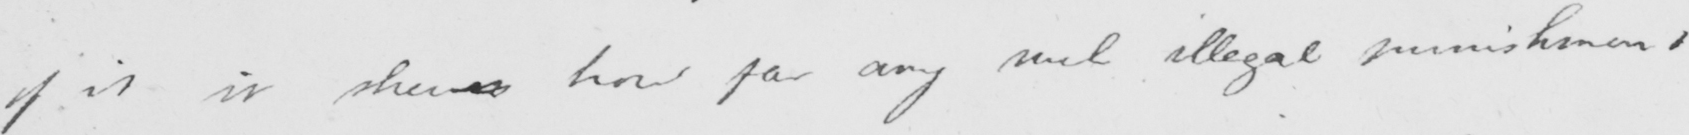Can you tell me what this handwritten text says? of it it shews how far any such illegal punishment 